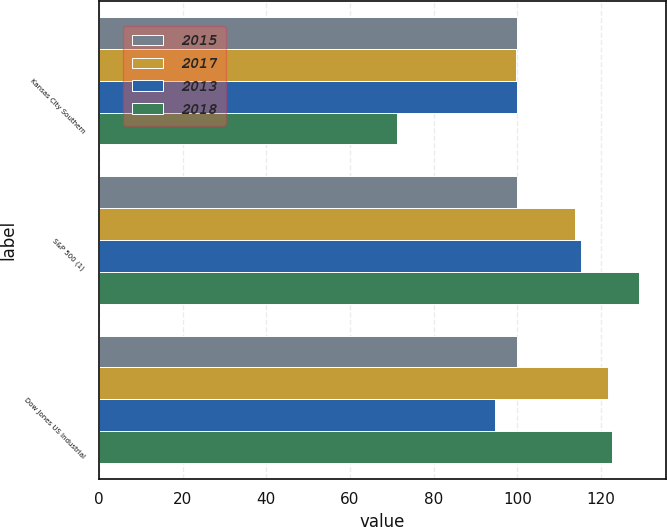Convert chart. <chart><loc_0><loc_0><loc_500><loc_500><stacked_bar_chart><ecel><fcel>Kansas City Southern<fcel>S&P 500 (1)<fcel>Dow Jones US Industrial<nl><fcel>2015<fcel>100<fcel>100<fcel>100<nl><fcel>2017<fcel>99.55<fcel>113.69<fcel>121.68<nl><fcel>2013<fcel>100<fcel>115.26<fcel>94.72<nl><fcel>2018<fcel>71.28<fcel>129.05<fcel>122.67<nl></chart> 